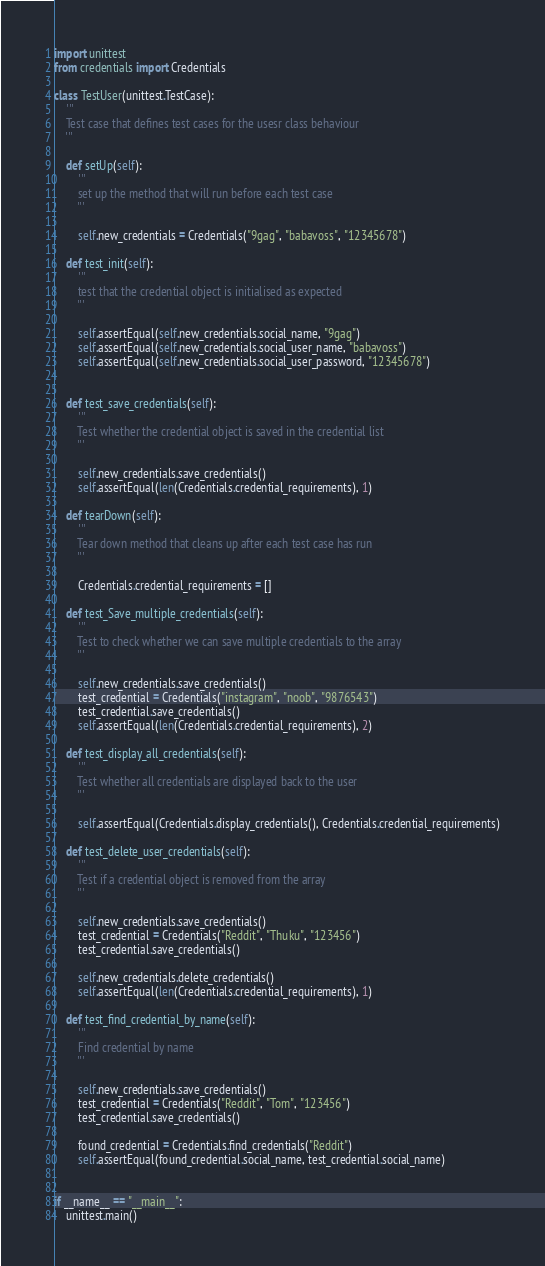<code> <loc_0><loc_0><loc_500><loc_500><_Python_>import unittest
from credentials import Credentials

class TestUser(unittest.TestCase):
    '''
    Test case that defines test cases for the usesr class behaviour
    '''

    def setUp(self):
        '''
        set up the method that will run before each test case
        '''

        self.new_credentials = Credentials("9gag", "babavoss", "12345678")

    def test_init(self):
        '''
        test that the credential object is initialised as expected
        '''

        self.assertEqual(self.new_credentials.social_name, "9gag")
        self.assertEqual(self.new_credentials.social_user_name, "babavoss")
        self.assertEqual(self.new_credentials.social_user_password, "12345678")


    def test_save_credentials(self):
        '''
        Test whether the credential object is saved in the credential list
        '''

        self.new_credentials.save_credentials()
        self.assertEqual(len(Credentials.credential_requirements), 1)

    def tearDown(self):
        '''
        Tear down method that cleans up after each test case has run
        '''

        Credentials.credential_requirements = []

    def test_Save_multiple_credentials(self):
        '''
        Test to check whether we can save multiple credentials to the array
        '''

        self.new_credentials.save_credentials()
        test_credential = Credentials("instagram", "noob", "9876543")
        test_credential.save_credentials()
        self.assertEqual(len(Credentials.credential_requirements), 2)

    def test_display_all_credentials(self):
        '''
        Test whether all credentials are displayed back to the user
        '''

        self.assertEqual(Credentials.display_credentials(), Credentials.credential_requirements)

    def test_delete_user_credentials(self):
        '''
        Test if a credential object is removed from the array
        '''

        self.new_credentials.save_credentials()
        test_credential = Credentials("Reddit", "Thuku", "123456")
        test_credential.save_credentials()

        self.new_credentials.delete_credentials()
        self.assertEqual(len(Credentials.credential_requirements), 1)

    def test_find_credential_by_name(self):
        '''
        Find credential by name
        '''

        self.new_credentials.save_credentials()
        test_credential = Credentials("Reddit", "Tom", "123456")
        test_credential.save_credentials()

        found_credential = Credentials.find_credentials("Reddit")
        self.assertEqual(found_credential.social_name, test_credential.social_name)


if __name__ == "__main__":
    unittest.main()</code> 